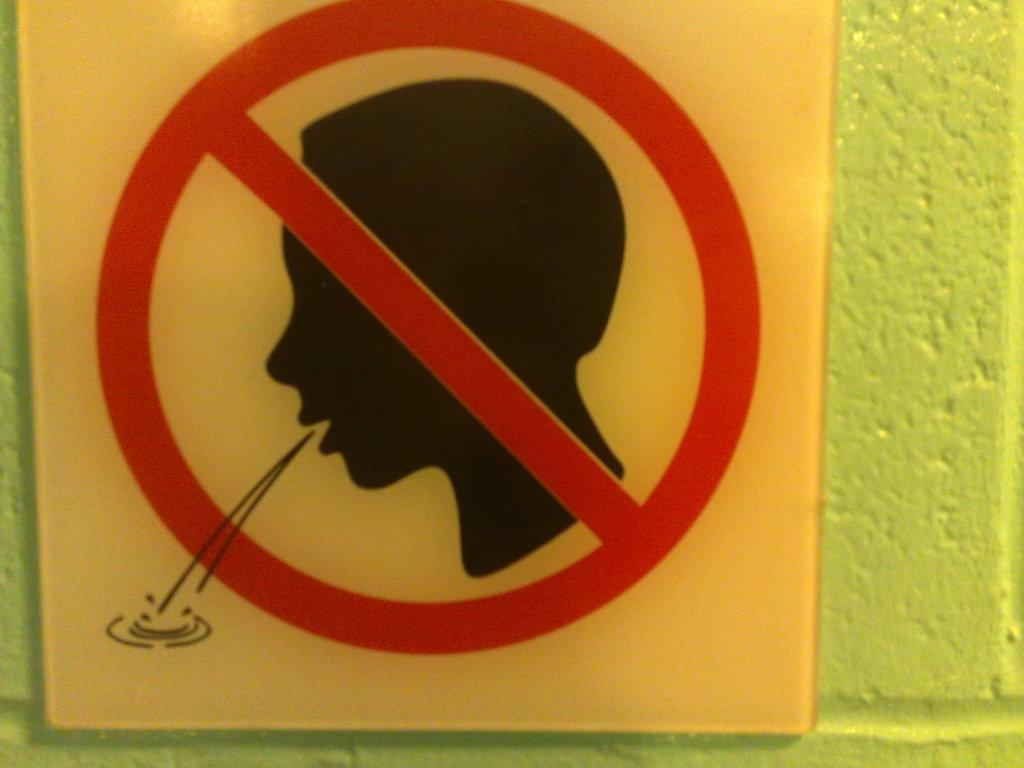What is the main object in the image? There is a board in the image. What color is the background of the image? The background of the image is green. Can you see any caves in the image? There are no caves present in the image; it features a board with a green background. What type of canvas is used to create the image? The image is not a painting or artwork, so there is no canvas involved in its creation. 